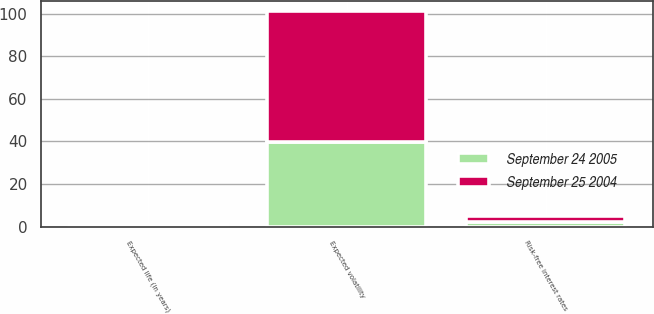Convert chart to OTSL. <chart><loc_0><loc_0><loc_500><loc_500><stacked_bar_chart><ecel><fcel>Risk-free interest rates<fcel>Expected life (in years)<fcel>Expected volatility<nl><fcel>September 24 2005<fcel>2.3<fcel>0.5<fcel>39.7<nl><fcel>September 25 2004<fcel>2.8<fcel>0.5<fcel>61.4<nl></chart> 